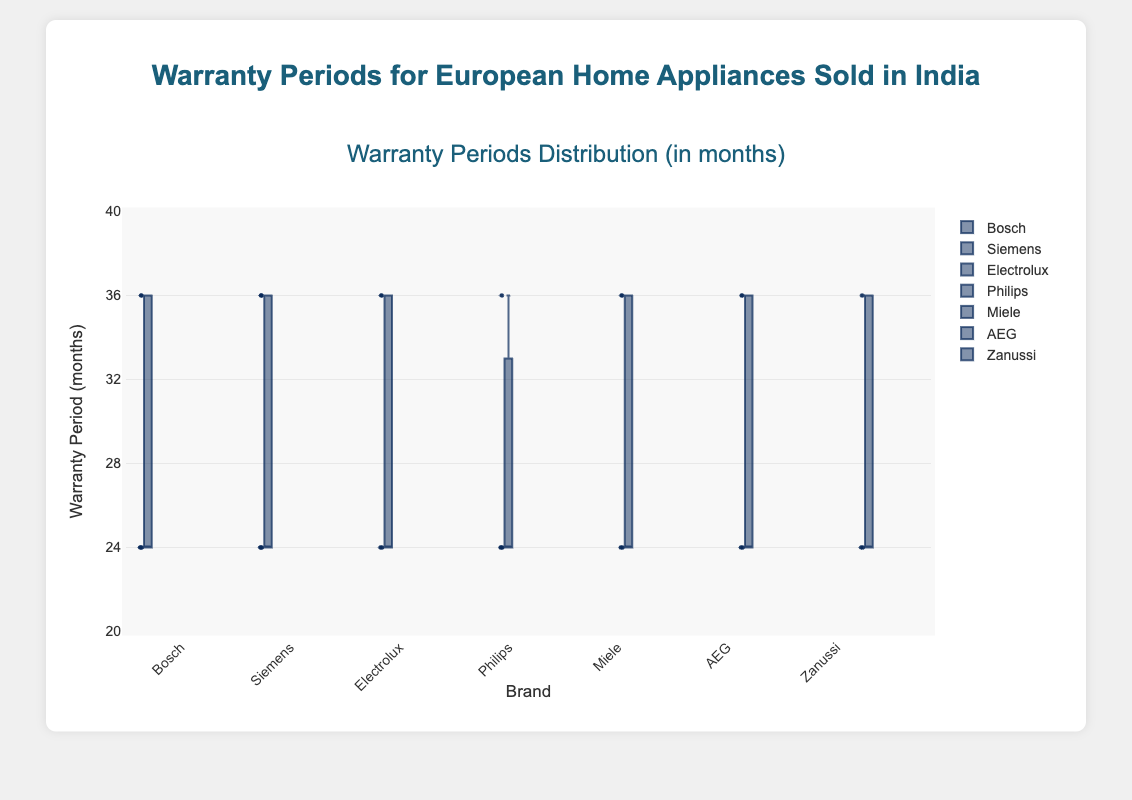What's the title of the plot? The title of the plot is shown at the top and summarizes the data being presented.
Answer: Warranty Periods for European Home Appliances Sold in India What is the range of the warranty periods displayed on the y-axis? The y-axis has the range of warranty periods displayed. The values start at 20 months and go up to 40 months.
Answer: 20 to 40 months Which brand has the widest spread in warranty periods? By looking at the boxplots, we can identify the brand with the largest IQR (Interquartile Range) and the overall spread between min and max values.
Answer: Siemens What is the median warranty period for Philips? The median value of Philips is identified by the line inside the box in the boxplot for Philips.
Answer: 24 months Are there more brands with a 24-month warranty period as the median or a 36-month warranty period as the median? By checking the median lines in each box, Philips, Bosch, Electrolux, and AEG have medians at 24 months, while Miele and Siemens have medians at 36 months.
Answer: More brands at 24 months Compare the upper quartile (75th percentile) of Electrolux and Miele. Which brand has a higher value? The upper quartile can be identified by the top edge of the box. By comparing the boxes for Electrolux and Miele, we see that Electrolux's upper quartile is at 36 months while Miele's is the same.
Answer: Both are equal at 36 months What are the outliers, if any, in Siemens's data? The outliers are the data points that fall outside the whiskers of the boxplot. Siemens does not have any such points outliers.
Answer: No outliers Which brand has the smallest interquartile range (IQR)? The IQR is the distance between the 25th and 75th percentiles, represented by the height of the box. Bosch, Philips, Electrolux, and AEG all have very similar IQRs.
Answer: Philips What is the maximum warranty period shown for Zanussi? The maximum warranty period for each brand is depicted by the tip of the upper whisker. For Zanussi, this is 36 months.
Answer: 36 months Which brands appear to have similar distributions of warranty periods? By visually comparing the shapes and positions of the boxes, Bosch, Electrolux, and AEG have very similar distributions suggesting similar warranty offerings.
Answer: Bosch, Electrolux, AEG 